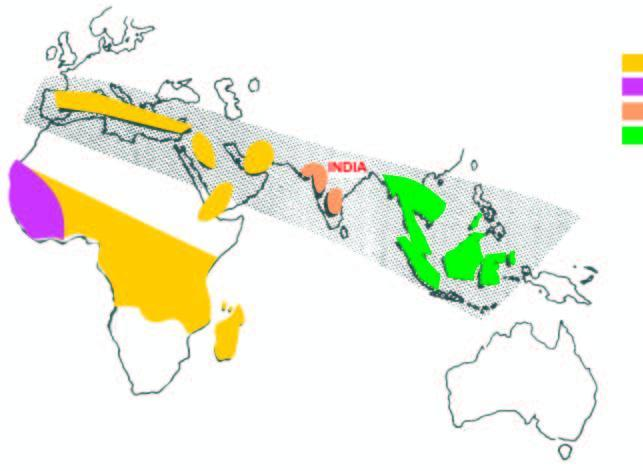where are thalassaemia and hbd disorders common?
Answer the question using a single word or phrase. India 